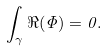Convert formula to latex. <formula><loc_0><loc_0><loc_500><loc_500>\int _ { \gamma } \Re ( \Phi ) = 0 .</formula> 